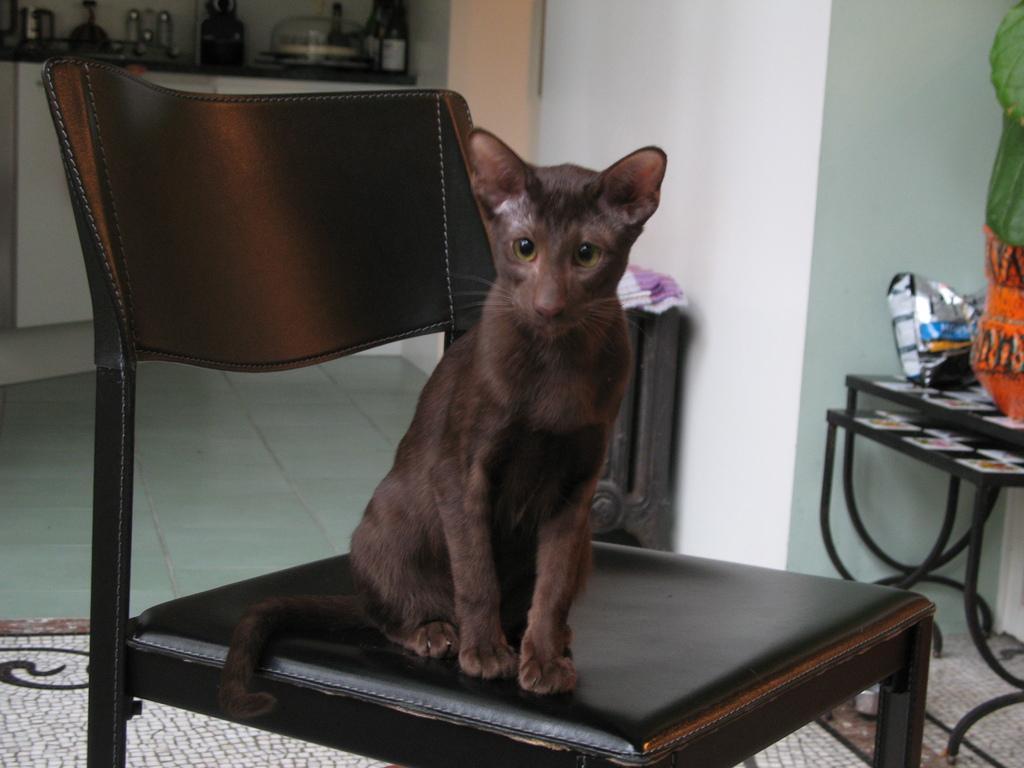How would you summarize this image in a sentence or two? In this image I can see a cat sitting on the chair. At the right there are some objects on the table. In the background there are some objects in the cupboard. 